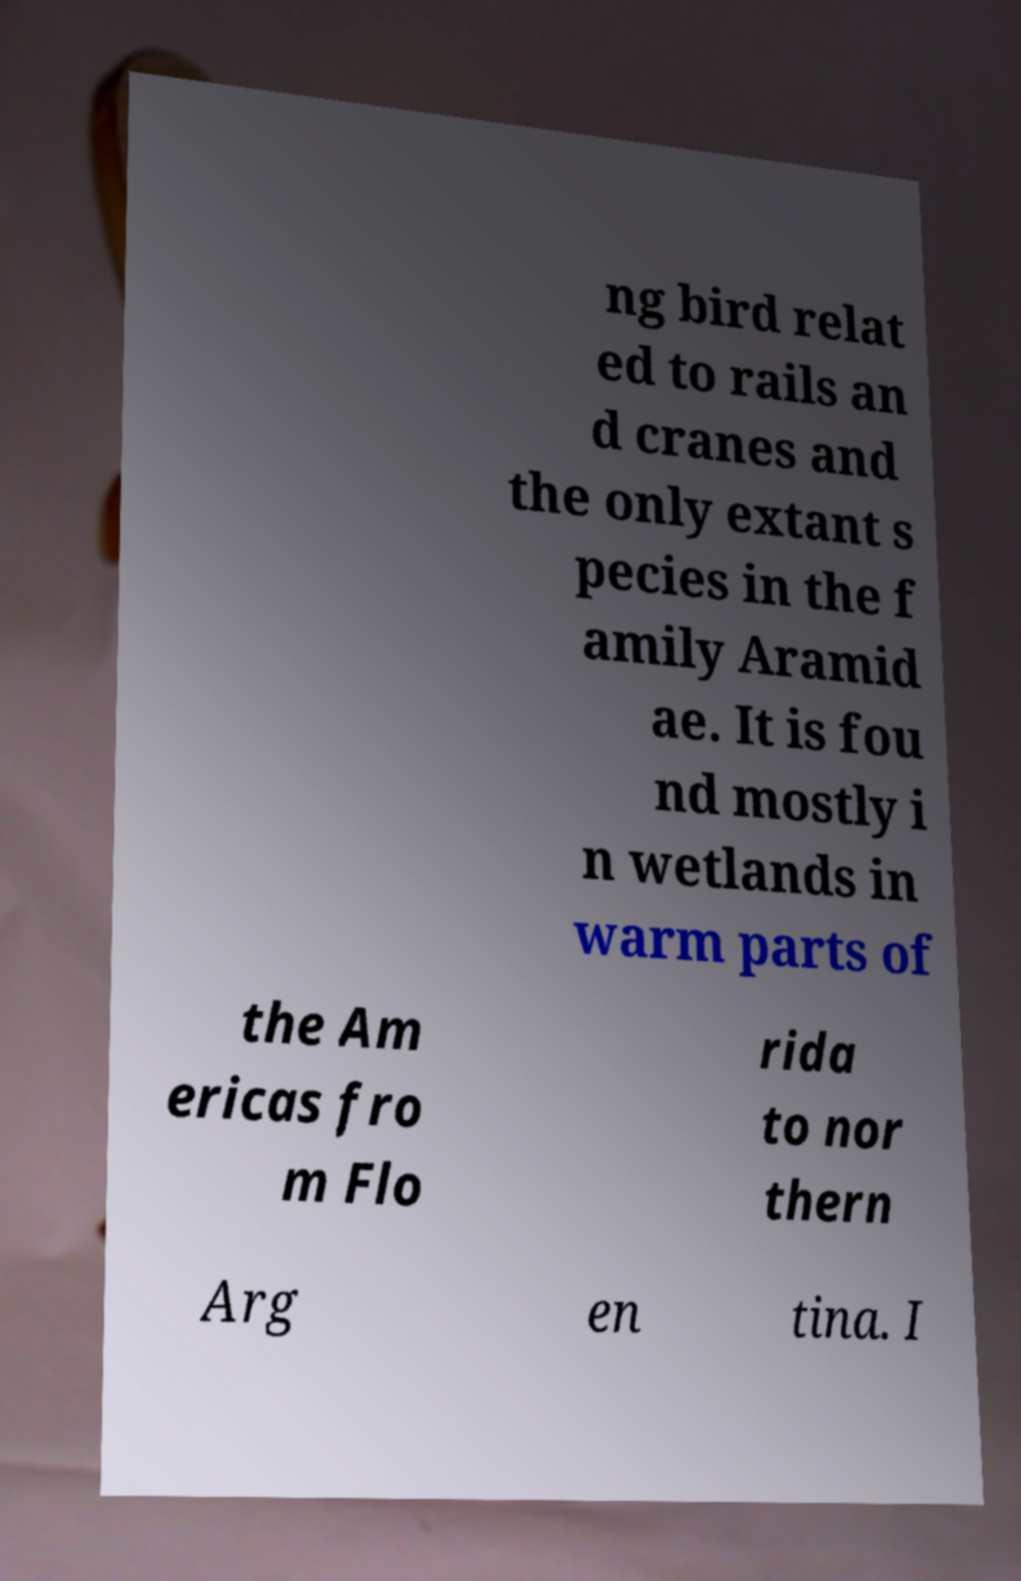There's text embedded in this image that I need extracted. Can you transcribe it verbatim? ng bird relat ed to rails an d cranes and the only extant s pecies in the f amily Aramid ae. It is fou nd mostly i n wetlands in warm parts of the Am ericas fro m Flo rida to nor thern Arg en tina. I 